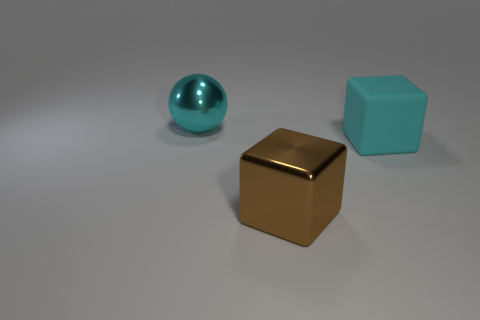What material is the brown thing that is the same shape as the cyan rubber thing?
Your response must be concise. Metal. Are there any metallic objects on the left side of the brown metal object?
Your response must be concise. Yes. There is a large metal thing behind the brown cube; is there a large sphere that is in front of it?
Make the answer very short. No. How many small objects are cyan things or yellow matte cylinders?
Make the answer very short. 0. The cyan thing that is behind the cyan object to the right of the brown block is made of what material?
Offer a very short reply. Metal. The large metallic object that is the same color as the matte object is what shape?
Provide a succinct answer. Sphere. Is there a small green object that has the same material as the brown block?
Ensure brevity in your answer.  No. Are the cyan ball and the thing in front of the cyan block made of the same material?
Ensure brevity in your answer.  Yes. The rubber cube that is the same size as the brown shiny cube is what color?
Your response must be concise. Cyan. What is the size of the cyan thing that is behind the cube right of the large brown thing?
Offer a terse response. Large. 